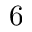<formula> <loc_0><loc_0><loc_500><loc_500>6</formula> 